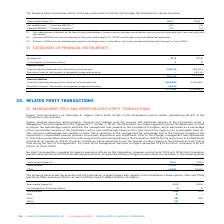According to Cogeco's financial document, What is the ownership of Cogeco in Cogeco Communications in terms of voting shares? According to the financial document, 82.3%. The relevant text states: "% of the Corporation's equity shares, representing 82.3% of the Corporation's voting shares...." Also, What was the management fee prior to the methodology change? 0.75% of the consolidated revenue from continuing and discontinued operations of the Corporation (0.85% for the period prior to the MetroCast acquisition on January 4, 2018). The document states: "Prior to this change, management fees represented 0.75% of the consolidated revenue from continuing and discontinued operations of the Corporation (0...." Also, What was the management fee paid to Cogeco in 2019? According to the financial document, $19.9 million. The relevant text states: "al 2019 management fees paid to Cogeco amounted to $19.9 million, compared to $19.0 million for fiscal 2018...." Also, can you calculate: What is the increase / (decrease) in the stock options from 2018 to 2019? Based on the calculation: 1,046 - 915, the result is 131 (in thousands). This is based on the information: "Stock options 1,046 915 Stock options 1,046 915..." The key data points involved are: 1,046, 915. Also, can you calculate: What was the average ISUs from 2018 to 2019? To answer this question, I need to perform calculations using the financial data. The calculation is: (61 + 1) / 2, which equals 31 (in thousands). This is based on the information: "ISUs 61 1 ISUs 61 1..." The key data points involved are: 61. Also, can you calculate: What was the average DSUs from 2018 to 2019? To answer this question, I need to perform calculations using the financial data. The calculation is: (631 + 0) / 2, which equals 315.5 (in thousands). This is based on the information: "Years ended August 31, 2019 2018 (3) DSUs 631 —..." The key data points involved are: 0, 631. 